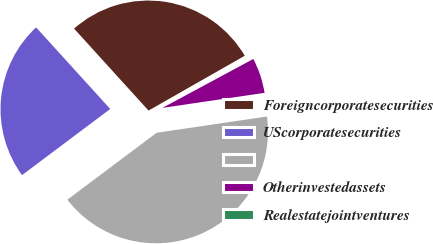Convert chart to OTSL. <chart><loc_0><loc_0><loc_500><loc_500><pie_chart><fcel>Foreigncorporatesecurities<fcel>UScorporatesecurities<fcel>Unnamed: 2<fcel>Otherinvestedassets<fcel>Realestatejointventures<nl><fcel>28.5%<fcel>23.5%<fcel>42.09%<fcel>5.53%<fcel>0.38%<nl></chart> 